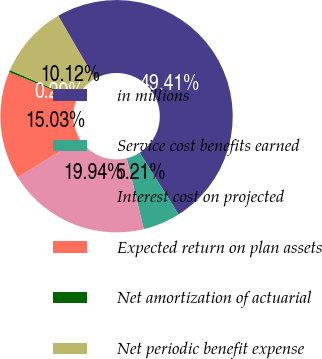Convert chart. <chart><loc_0><loc_0><loc_500><loc_500><pie_chart><fcel>in millions<fcel>Service cost benefits earned<fcel>Interest cost on projected<fcel>Expected return on plan assets<fcel>Net amortization of actuarial<fcel>Net periodic benefit expense<nl><fcel>49.41%<fcel>5.21%<fcel>19.94%<fcel>15.03%<fcel>0.29%<fcel>10.12%<nl></chart> 